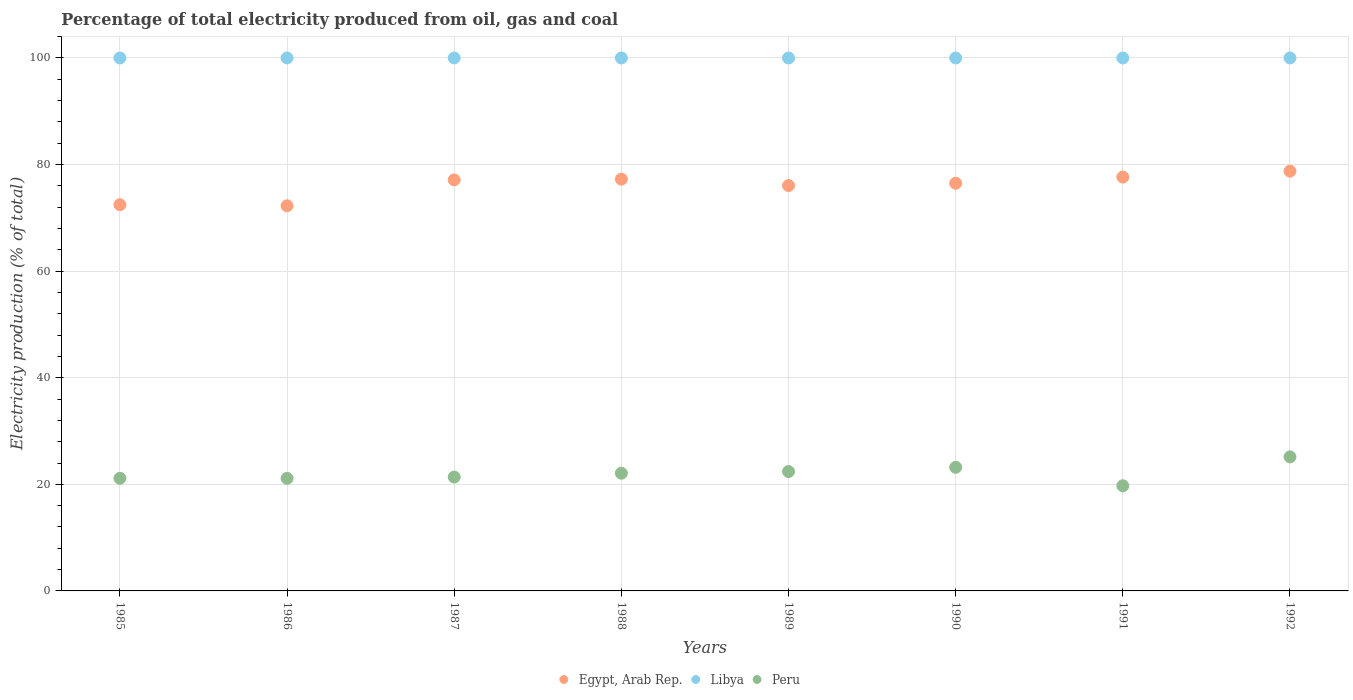Is the number of dotlines equal to the number of legend labels?
Your answer should be very brief. Yes. What is the electricity production in in Peru in 1985?
Offer a very short reply. 21.14. Across all years, what is the minimum electricity production in in Libya?
Offer a very short reply. 100. In which year was the electricity production in in Libya maximum?
Your response must be concise. 1985. In which year was the electricity production in in Egypt, Arab Rep. minimum?
Your answer should be very brief. 1986. What is the total electricity production in in Egypt, Arab Rep. in the graph?
Your answer should be very brief. 608.07. What is the difference between the electricity production in in Peru in 1987 and that in 1992?
Your answer should be compact. -3.79. What is the difference between the electricity production in in Peru in 1985 and the electricity production in in Libya in 1989?
Give a very brief answer. -78.86. What is the average electricity production in in Egypt, Arab Rep. per year?
Provide a succinct answer. 76.01. In the year 1992, what is the difference between the electricity production in in Peru and electricity production in in Egypt, Arab Rep.?
Ensure brevity in your answer.  -53.62. What is the ratio of the electricity production in in Egypt, Arab Rep. in 1987 to that in 1989?
Your response must be concise. 1.01. Is the difference between the electricity production in in Peru in 1987 and 1988 greater than the difference between the electricity production in in Egypt, Arab Rep. in 1987 and 1988?
Offer a very short reply. No. What is the difference between the highest and the second highest electricity production in in Peru?
Your answer should be compact. 1.95. What is the difference between the highest and the lowest electricity production in in Libya?
Provide a short and direct response. 0. In how many years, is the electricity production in in Egypt, Arab Rep. greater than the average electricity production in in Egypt, Arab Rep. taken over all years?
Provide a succinct answer. 6. Does the electricity production in in Egypt, Arab Rep. monotonically increase over the years?
Provide a succinct answer. No. Is the electricity production in in Egypt, Arab Rep. strictly less than the electricity production in in Libya over the years?
Make the answer very short. Yes. How many dotlines are there?
Offer a very short reply. 3. How many years are there in the graph?
Your response must be concise. 8. What is the difference between two consecutive major ticks on the Y-axis?
Provide a succinct answer. 20. Does the graph contain any zero values?
Keep it short and to the point. No. Where does the legend appear in the graph?
Make the answer very short. Bottom center. How many legend labels are there?
Offer a very short reply. 3. What is the title of the graph?
Your response must be concise. Percentage of total electricity produced from oil, gas and coal. What is the label or title of the X-axis?
Provide a succinct answer. Years. What is the label or title of the Y-axis?
Ensure brevity in your answer.  Electricity production (% of total). What is the Electricity production (% of total) of Egypt, Arab Rep. in 1985?
Your answer should be very brief. 72.46. What is the Electricity production (% of total) of Peru in 1985?
Keep it short and to the point. 21.14. What is the Electricity production (% of total) in Egypt, Arab Rep. in 1986?
Provide a succinct answer. 72.27. What is the Electricity production (% of total) in Peru in 1986?
Provide a succinct answer. 21.12. What is the Electricity production (% of total) in Egypt, Arab Rep. in 1987?
Offer a very short reply. 77.12. What is the Electricity production (% of total) in Peru in 1987?
Provide a succinct answer. 21.36. What is the Electricity production (% of total) in Egypt, Arab Rep. in 1988?
Your answer should be very brief. 77.26. What is the Electricity production (% of total) of Libya in 1988?
Offer a very short reply. 100. What is the Electricity production (% of total) in Peru in 1988?
Provide a short and direct response. 22.09. What is the Electricity production (% of total) of Egypt, Arab Rep. in 1989?
Your answer should be compact. 76.05. What is the Electricity production (% of total) in Libya in 1989?
Ensure brevity in your answer.  100. What is the Electricity production (% of total) of Peru in 1989?
Ensure brevity in your answer.  22.4. What is the Electricity production (% of total) in Egypt, Arab Rep. in 1990?
Ensure brevity in your answer.  76.5. What is the Electricity production (% of total) of Libya in 1990?
Offer a terse response. 100. What is the Electricity production (% of total) of Peru in 1990?
Your answer should be compact. 23.2. What is the Electricity production (% of total) in Egypt, Arab Rep. in 1991?
Your answer should be compact. 77.65. What is the Electricity production (% of total) of Libya in 1991?
Your response must be concise. 100. What is the Electricity production (% of total) in Peru in 1991?
Provide a short and direct response. 19.73. What is the Electricity production (% of total) of Egypt, Arab Rep. in 1992?
Provide a short and direct response. 78.76. What is the Electricity production (% of total) of Peru in 1992?
Your response must be concise. 25.15. Across all years, what is the maximum Electricity production (% of total) of Egypt, Arab Rep.?
Offer a very short reply. 78.76. Across all years, what is the maximum Electricity production (% of total) of Peru?
Provide a short and direct response. 25.15. Across all years, what is the minimum Electricity production (% of total) of Egypt, Arab Rep.?
Offer a very short reply. 72.27. Across all years, what is the minimum Electricity production (% of total) of Libya?
Your answer should be very brief. 100. Across all years, what is the minimum Electricity production (% of total) of Peru?
Provide a short and direct response. 19.73. What is the total Electricity production (% of total) in Egypt, Arab Rep. in the graph?
Provide a succinct answer. 608.07. What is the total Electricity production (% of total) in Libya in the graph?
Offer a terse response. 800. What is the total Electricity production (% of total) in Peru in the graph?
Give a very brief answer. 176.18. What is the difference between the Electricity production (% of total) of Egypt, Arab Rep. in 1985 and that in 1986?
Ensure brevity in your answer.  0.2. What is the difference between the Electricity production (% of total) in Peru in 1985 and that in 1986?
Provide a succinct answer. 0.02. What is the difference between the Electricity production (% of total) in Egypt, Arab Rep. in 1985 and that in 1987?
Ensure brevity in your answer.  -4.66. What is the difference between the Electricity production (% of total) in Libya in 1985 and that in 1987?
Provide a short and direct response. 0. What is the difference between the Electricity production (% of total) in Peru in 1985 and that in 1987?
Keep it short and to the point. -0.22. What is the difference between the Electricity production (% of total) of Egypt, Arab Rep. in 1985 and that in 1988?
Provide a short and direct response. -4.8. What is the difference between the Electricity production (% of total) in Libya in 1985 and that in 1988?
Ensure brevity in your answer.  0. What is the difference between the Electricity production (% of total) of Peru in 1985 and that in 1988?
Your answer should be very brief. -0.95. What is the difference between the Electricity production (% of total) of Egypt, Arab Rep. in 1985 and that in 1989?
Ensure brevity in your answer.  -3.59. What is the difference between the Electricity production (% of total) of Peru in 1985 and that in 1989?
Your answer should be compact. -1.26. What is the difference between the Electricity production (% of total) in Egypt, Arab Rep. in 1985 and that in 1990?
Offer a terse response. -4.03. What is the difference between the Electricity production (% of total) of Libya in 1985 and that in 1990?
Give a very brief answer. 0. What is the difference between the Electricity production (% of total) of Peru in 1985 and that in 1990?
Give a very brief answer. -2.06. What is the difference between the Electricity production (% of total) in Egypt, Arab Rep. in 1985 and that in 1991?
Offer a terse response. -5.19. What is the difference between the Electricity production (% of total) of Peru in 1985 and that in 1991?
Give a very brief answer. 1.41. What is the difference between the Electricity production (% of total) of Egypt, Arab Rep. in 1985 and that in 1992?
Give a very brief answer. -6.3. What is the difference between the Electricity production (% of total) of Libya in 1985 and that in 1992?
Offer a very short reply. 0. What is the difference between the Electricity production (% of total) of Peru in 1985 and that in 1992?
Ensure brevity in your answer.  -4.01. What is the difference between the Electricity production (% of total) of Egypt, Arab Rep. in 1986 and that in 1987?
Ensure brevity in your answer.  -4.86. What is the difference between the Electricity production (% of total) of Libya in 1986 and that in 1987?
Keep it short and to the point. 0. What is the difference between the Electricity production (% of total) in Peru in 1986 and that in 1987?
Offer a terse response. -0.25. What is the difference between the Electricity production (% of total) in Egypt, Arab Rep. in 1986 and that in 1988?
Provide a succinct answer. -5. What is the difference between the Electricity production (% of total) of Peru in 1986 and that in 1988?
Offer a very short reply. -0.97. What is the difference between the Electricity production (% of total) in Egypt, Arab Rep. in 1986 and that in 1989?
Give a very brief answer. -3.79. What is the difference between the Electricity production (% of total) of Peru in 1986 and that in 1989?
Offer a very short reply. -1.29. What is the difference between the Electricity production (% of total) in Egypt, Arab Rep. in 1986 and that in 1990?
Your answer should be compact. -4.23. What is the difference between the Electricity production (% of total) of Peru in 1986 and that in 1990?
Give a very brief answer. -2.08. What is the difference between the Electricity production (% of total) of Egypt, Arab Rep. in 1986 and that in 1991?
Offer a terse response. -5.38. What is the difference between the Electricity production (% of total) of Peru in 1986 and that in 1991?
Offer a very short reply. 1.39. What is the difference between the Electricity production (% of total) of Egypt, Arab Rep. in 1986 and that in 1992?
Offer a terse response. -6.5. What is the difference between the Electricity production (% of total) in Libya in 1986 and that in 1992?
Give a very brief answer. 0. What is the difference between the Electricity production (% of total) of Peru in 1986 and that in 1992?
Offer a terse response. -4.03. What is the difference between the Electricity production (% of total) of Egypt, Arab Rep. in 1987 and that in 1988?
Give a very brief answer. -0.14. What is the difference between the Electricity production (% of total) in Libya in 1987 and that in 1988?
Provide a short and direct response. 0. What is the difference between the Electricity production (% of total) of Peru in 1987 and that in 1988?
Make the answer very short. -0.72. What is the difference between the Electricity production (% of total) of Egypt, Arab Rep. in 1987 and that in 1989?
Ensure brevity in your answer.  1.07. What is the difference between the Electricity production (% of total) in Libya in 1987 and that in 1989?
Make the answer very short. 0. What is the difference between the Electricity production (% of total) of Peru in 1987 and that in 1989?
Keep it short and to the point. -1.04. What is the difference between the Electricity production (% of total) of Egypt, Arab Rep. in 1987 and that in 1990?
Your response must be concise. 0.63. What is the difference between the Electricity production (% of total) in Libya in 1987 and that in 1990?
Your answer should be very brief. 0. What is the difference between the Electricity production (% of total) of Peru in 1987 and that in 1990?
Give a very brief answer. -1.83. What is the difference between the Electricity production (% of total) of Egypt, Arab Rep. in 1987 and that in 1991?
Keep it short and to the point. -0.53. What is the difference between the Electricity production (% of total) of Peru in 1987 and that in 1991?
Keep it short and to the point. 1.63. What is the difference between the Electricity production (% of total) of Egypt, Arab Rep. in 1987 and that in 1992?
Give a very brief answer. -1.64. What is the difference between the Electricity production (% of total) in Peru in 1987 and that in 1992?
Offer a terse response. -3.79. What is the difference between the Electricity production (% of total) of Egypt, Arab Rep. in 1988 and that in 1989?
Your answer should be very brief. 1.21. What is the difference between the Electricity production (% of total) in Libya in 1988 and that in 1989?
Provide a short and direct response. 0. What is the difference between the Electricity production (% of total) of Peru in 1988 and that in 1989?
Offer a very short reply. -0.32. What is the difference between the Electricity production (% of total) of Egypt, Arab Rep. in 1988 and that in 1990?
Keep it short and to the point. 0.77. What is the difference between the Electricity production (% of total) of Libya in 1988 and that in 1990?
Your answer should be very brief. 0. What is the difference between the Electricity production (% of total) in Peru in 1988 and that in 1990?
Ensure brevity in your answer.  -1.11. What is the difference between the Electricity production (% of total) in Egypt, Arab Rep. in 1988 and that in 1991?
Provide a succinct answer. -0.39. What is the difference between the Electricity production (% of total) in Peru in 1988 and that in 1991?
Give a very brief answer. 2.36. What is the difference between the Electricity production (% of total) in Egypt, Arab Rep. in 1988 and that in 1992?
Give a very brief answer. -1.5. What is the difference between the Electricity production (% of total) of Libya in 1988 and that in 1992?
Your answer should be compact. 0. What is the difference between the Electricity production (% of total) in Peru in 1988 and that in 1992?
Provide a short and direct response. -3.06. What is the difference between the Electricity production (% of total) of Egypt, Arab Rep. in 1989 and that in 1990?
Your response must be concise. -0.44. What is the difference between the Electricity production (% of total) in Libya in 1989 and that in 1990?
Your answer should be very brief. 0. What is the difference between the Electricity production (% of total) in Peru in 1989 and that in 1990?
Offer a very short reply. -0.8. What is the difference between the Electricity production (% of total) in Egypt, Arab Rep. in 1989 and that in 1991?
Your answer should be compact. -1.6. What is the difference between the Electricity production (% of total) of Libya in 1989 and that in 1991?
Offer a terse response. 0. What is the difference between the Electricity production (% of total) in Peru in 1989 and that in 1991?
Your answer should be compact. 2.67. What is the difference between the Electricity production (% of total) in Egypt, Arab Rep. in 1989 and that in 1992?
Your answer should be compact. -2.71. What is the difference between the Electricity production (% of total) in Libya in 1989 and that in 1992?
Provide a short and direct response. 0. What is the difference between the Electricity production (% of total) of Peru in 1989 and that in 1992?
Provide a succinct answer. -2.75. What is the difference between the Electricity production (% of total) of Egypt, Arab Rep. in 1990 and that in 1991?
Your answer should be compact. -1.15. What is the difference between the Electricity production (% of total) in Libya in 1990 and that in 1991?
Give a very brief answer. 0. What is the difference between the Electricity production (% of total) in Peru in 1990 and that in 1991?
Keep it short and to the point. 3.47. What is the difference between the Electricity production (% of total) in Egypt, Arab Rep. in 1990 and that in 1992?
Provide a succinct answer. -2.27. What is the difference between the Electricity production (% of total) of Libya in 1990 and that in 1992?
Your answer should be compact. 0. What is the difference between the Electricity production (% of total) of Peru in 1990 and that in 1992?
Your answer should be compact. -1.95. What is the difference between the Electricity production (% of total) of Egypt, Arab Rep. in 1991 and that in 1992?
Provide a succinct answer. -1.11. What is the difference between the Electricity production (% of total) of Peru in 1991 and that in 1992?
Provide a short and direct response. -5.42. What is the difference between the Electricity production (% of total) in Egypt, Arab Rep. in 1985 and the Electricity production (% of total) in Libya in 1986?
Your answer should be very brief. -27.54. What is the difference between the Electricity production (% of total) in Egypt, Arab Rep. in 1985 and the Electricity production (% of total) in Peru in 1986?
Your answer should be compact. 51.35. What is the difference between the Electricity production (% of total) in Libya in 1985 and the Electricity production (% of total) in Peru in 1986?
Keep it short and to the point. 78.88. What is the difference between the Electricity production (% of total) of Egypt, Arab Rep. in 1985 and the Electricity production (% of total) of Libya in 1987?
Offer a very short reply. -27.54. What is the difference between the Electricity production (% of total) of Egypt, Arab Rep. in 1985 and the Electricity production (% of total) of Peru in 1987?
Ensure brevity in your answer.  51.1. What is the difference between the Electricity production (% of total) in Libya in 1985 and the Electricity production (% of total) in Peru in 1987?
Offer a terse response. 78.64. What is the difference between the Electricity production (% of total) in Egypt, Arab Rep. in 1985 and the Electricity production (% of total) in Libya in 1988?
Your answer should be compact. -27.54. What is the difference between the Electricity production (% of total) in Egypt, Arab Rep. in 1985 and the Electricity production (% of total) in Peru in 1988?
Offer a terse response. 50.38. What is the difference between the Electricity production (% of total) in Libya in 1985 and the Electricity production (% of total) in Peru in 1988?
Your answer should be very brief. 77.91. What is the difference between the Electricity production (% of total) in Egypt, Arab Rep. in 1985 and the Electricity production (% of total) in Libya in 1989?
Provide a succinct answer. -27.54. What is the difference between the Electricity production (% of total) of Egypt, Arab Rep. in 1985 and the Electricity production (% of total) of Peru in 1989?
Provide a succinct answer. 50.06. What is the difference between the Electricity production (% of total) in Libya in 1985 and the Electricity production (% of total) in Peru in 1989?
Provide a short and direct response. 77.6. What is the difference between the Electricity production (% of total) of Egypt, Arab Rep. in 1985 and the Electricity production (% of total) of Libya in 1990?
Make the answer very short. -27.54. What is the difference between the Electricity production (% of total) of Egypt, Arab Rep. in 1985 and the Electricity production (% of total) of Peru in 1990?
Your response must be concise. 49.27. What is the difference between the Electricity production (% of total) of Libya in 1985 and the Electricity production (% of total) of Peru in 1990?
Ensure brevity in your answer.  76.8. What is the difference between the Electricity production (% of total) in Egypt, Arab Rep. in 1985 and the Electricity production (% of total) in Libya in 1991?
Offer a terse response. -27.54. What is the difference between the Electricity production (% of total) of Egypt, Arab Rep. in 1985 and the Electricity production (% of total) of Peru in 1991?
Offer a terse response. 52.73. What is the difference between the Electricity production (% of total) in Libya in 1985 and the Electricity production (% of total) in Peru in 1991?
Ensure brevity in your answer.  80.27. What is the difference between the Electricity production (% of total) in Egypt, Arab Rep. in 1985 and the Electricity production (% of total) in Libya in 1992?
Your response must be concise. -27.54. What is the difference between the Electricity production (% of total) of Egypt, Arab Rep. in 1985 and the Electricity production (% of total) of Peru in 1992?
Your answer should be compact. 47.31. What is the difference between the Electricity production (% of total) of Libya in 1985 and the Electricity production (% of total) of Peru in 1992?
Offer a terse response. 74.85. What is the difference between the Electricity production (% of total) of Egypt, Arab Rep. in 1986 and the Electricity production (% of total) of Libya in 1987?
Your answer should be compact. -27.73. What is the difference between the Electricity production (% of total) in Egypt, Arab Rep. in 1986 and the Electricity production (% of total) in Peru in 1987?
Offer a very short reply. 50.9. What is the difference between the Electricity production (% of total) of Libya in 1986 and the Electricity production (% of total) of Peru in 1987?
Offer a very short reply. 78.64. What is the difference between the Electricity production (% of total) in Egypt, Arab Rep. in 1986 and the Electricity production (% of total) in Libya in 1988?
Ensure brevity in your answer.  -27.73. What is the difference between the Electricity production (% of total) in Egypt, Arab Rep. in 1986 and the Electricity production (% of total) in Peru in 1988?
Your answer should be very brief. 50.18. What is the difference between the Electricity production (% of total) of Libya in 1986 and the Electricity production (% of total) of Peru in 1988?
Provide a succinct answer. 77.91. What is the difference between the Electricity production (% of total) in Egypt, Arab Rep. in 1986 and the Electricity production (% of total) in Libya in 1989?
Keep it short and to the point. -27.73. What is the difference between the Electricity production (% of total) of Egypt, Arab Rep. in 1986 and the Electricity production (% of total) of Peru in 1989?
Ensure brevity in your answer.  49.86. What is the difference between the Electricity production (% of total) in Libya in 1986 and the Electricity production (% of total) in Peru in 1989?
Make the answer very short. 77.6. What is the difference between the Electricity production (% of total) in Egypt, Arab Rep. in 1986 and the Electricity production (% of total) in Libya in 1990?
Your answer should be very brief. -27.73. What is the difference between the Electricity production (% of total) of Egypt, Arab Rep. in 1986 and the Electricity production (% of total) of Peru in 1990?
Provide a short and direct response. 49.07. What is the difference between the Electricity production (% of total) of Libya in 1986 and the Electricity production (% of total) of Peru in 1990?
Your answer should be very brief. 76.8. What is the difference between the Electricity production (% of total) of Egypt, Arab Rep. in 1986 and the Electricity production (% of total) of Libya in 1991?
Provide a succinct answer. -27.73. What is the difference between the Electricity production (% of total) of Egypt, Arab Rep. in 1986 and the Electricity production (% of total) of Peru in 1991?
Ensure brevity in your answer.  52.54. What is the difference between the Electricity production (% of total) of Libya in 1986 and the Electricity production (% of total) of Peru in 1991?
Provide a short and direct response. 80.27. What is the difference between the Electricity production (% of total) in Egypt, Arab Rep. in 1986 and the Electricity production (% of total) in Libya in 1992?
Keep it short and to the point. -27.73. What is the difference between the Electricity production (% of total) of Egypt, Arab Rep. in 1986 and the Electricity production (% of total) of Peru in 1992?
Ensure brevity in your answer.  47.12. What is the difference between the Electricity production (% of total) of Libya in 1986 and the Electricity production (% of total) of Peru in 1992?
Give a very brief answer. 74.85. What is the difference between the Electricity production (% of total) of Egypt, Arab Rep. in 1987 and the Electricity production (% of total) of Libya in 1988?
Your answer should be compact. -22.88. What is the difference between the Electricity production (% of total) in Egypt, Arab Rep. in 1987 and the Electricity production (% of total) in Peru in 1988?
Keep it short and to the point. 55.04. What is the difference between the Electricity production (% of total) of Libya in 1987 and the Electricity production (% of total) of Peru in 1988?
Offer a very short reply. 77.91. What is the difference between the Electricity production (% of total) of Egypt, Arab Rep. in 1987 and the Electricity production (% of total) of Libya in 1989?
Provide a succinct answer. -22.88. What is the difference between the Electricity production (% of total) of Egypt, Arab Rep. in 1987 and the Electricity production (% of total) of Peru in 1989?
Provide a succinct answer. 54.72. What is the difference between the Electricity production (% of total) of Libya in 1987 and the Electricity production (% of total) of Peru in 1989?
Your answer should be compact. 77.6. What is the difference between the Electricity production (% of total) of Egypt, Arab Rep. in 1987 and the Electricity production (% of total) of Libya in 1990?
Offer a terse response. -22.88. What is the difference between the Electricity production (% of total) in Egypt, Arab Rep. in 1987 and the Electricity production (% of total) in Peru in 1990?
Offer a terse response. 53.93. What is the difference between the Electricity production (% of total) of Libya in 1987 and the Electricity production (% of total) of Peru in 1990?
Keep it short and to the point. 76.8. What is the difference between the Electricity production (% of total) of Egypt, Arab Rep. in 1987 and the Electricity production (% of total) of Libya in 1991?
Your answer should be very brief. -22.88. What is the difference between the Electricity production (% of total) in Egypt, Arab Rep. in 1987 and the Electricity production (% of total) in Peru in 1991?
Give a very brief answer. 57.39. What is the difference between the Electricity production (% of total) of Libya in 1987 and the Electricity production (% of total) of Peru in 1991?
Your answer should be compact. 80.27. What is the difference between the Electricity production (% of total) in Egypt, Arab Rep. in 1987 and the Electricity production (% of total) in Libya in 1992?
Keep it short and to the point. -22.88. What is the difference between the Electricity production (% of total) in Egypt, Arab Rep. in 1987 and the Electricity production (% of total) in Peru in 1992?
Make the answer very short. 51.97. What is the difference between the Electricity production (% of total) of Libya in 1987 and the Electricity production (% of total) of Peru in 1992?
Provide a short and direct response. 74.85. What is the difference between the Electricity production (% of total) of Egypt, Arab Rep. in 1988 and the Electricity production (% of total) of Libya in 1989?
Give a very brief answer. -22.74. What is the difference between the Electricity production (% of total) in Egypt, Arab Rep. in 1988 and the Electricity production (% of total) in Peru in 1989?
Offer a terse response. 54.86. What is the difference between the Electricity production (% of total) of Libya in 1988 and the Electricity production (% of total) of Peru in 1989?
Your answer should be very brief. 77.6. What is the difference between the Electricity production (% of total) of Egypt, Arab Rep. in 1988 and the Electricity production (% of total) of Libya in 1990?
Give a very brief answer. -22.74. What is the difference between the Electricity production (% of total) in Egypt, Arab Rep. in 1988 and the Electricity production (% of total) in Peru in 1990?
Ensure brevity in your answer.  54.06. What is the difference between the Electricity production (% of total) of Libya in 1988 and the Electricity production (% of total) of Peru in 1990?
Ensure brevity in your answer.  76.8. What is the difference between the Electricity production (% of total) of Egypt, Arab Rep. in 1988 and the Electricity production (% of total) of Libya in 1991?
Offer a very short reply. -22.74. What is the difference between the Electricity production (% of total) in Egypt, Arab Rep. in 1988 and the Electricity production (% of total) in Peru in 1991?
Ensure brevity in your answer.  57.53. What is the difference between the Electricity production (% of total) in Libya in 1988 and the Electricity production (% of total) in Peru in 1991?
Your answer should be compact. 80.27. What is the difference between the Electricity production (% of total) of Egypt, Arab Rep. in 1988 and the Electricity production (% of total) of Libya in 1992?
Keep it short and to the point. -22.74. What is the difference between the Electricity production (% of total) of Egypt, Arab Rep. in 1988 and the Electricity production (% of total) of Peru in 1992?
Offer a very short reply. 52.11. What is the difference between the Electricity production (% of total) of Libya in 1988 and the Electricity production (% of total) of Peru in 1992?
Ensure brevity in your answer.  74.85. What is the difference between the Electricity production (% of total) of Egypt, Arab Rep. in 1989 and the Electricity production (% of total) of Libya in 1990?
Give a very brief answer. -23.95. What is the difference between the Electricity production (% of total) of Egypt, Arab Rep. in 1989 and the Electricity production (% of total) of Peru in 1990?
Offer a very short reply. 52.86. What is the difference between the Electricity production (% of total) in Libya in 1989 and the Electricity production (% of total) in Peru in 1990?
Your answer should be compact. 76.8. What is the difference between the Electricity production (% of total) in Egypt, Arab Rep. in 1989 and the Electricity production (% of total) in Libya in 1991?
Offer a very short reply. -23.95. What is the difference between the Electricity production (% of total) of Egypt, Arab Rep. in 1989 and the Electricity production (% of total) of Peru in 1991?
Provide a succinct answer. 56.32. What is the difference between the Electricity production (% of total) of Libya in 1989 and the Electricity production (% of total) of Peru in 1991?
Your answer should be compact. 80.27. What is the difference between the Electricity production (% of total) of Egypt, Arab Rep. in 1989 and the Electricity production (% of total) of Libya in 1992?
Your answer should be very brief. -23.95. What is the difference between the Electricity production (% of total) of Egypt, Arab Rep. in 1989 and the Electricity production (% of total) of Peru in 1992?
Offer a very short reply. 50.9. What is the difference between the Electricity production (% of total) in Libya in 1989 and the Electricity production (% of total) in Peru in 1992?
Your response must be concise. 74.85. What is the difference between the Electricity production (% of total) of Egypt, Arab Rep. in 1990 and the Electricity production (% of total) of Libya in 1991?
Give a very brief answer. -23.5. What is the difference between the Electricity production (% of total) in Egypt, Arab Rep. in 1990 and the Electricity production (% of total) in Peru in 1991?
Make the answer very short. 56.77. What is the difference between the Electricity production (% of total) in Libya in 1990 and the Electricity production (% of total) in Peru in 1991?
Ensure brevity in your answer.  80.27. What is the difference between the Electricity production (% of total) in Egypt, Arab Rep. in 1990 and the Electricity production (% of total) in Libya in 1992?
Ensure brevity in your answer.  -23.5. What is the difference between the Electricity production (% of total) in Egypt, Arab Rep. in 1990 and the Electricity production (% of total) in Peru in 1992?
Your response must be concise. 51.35. What is the difference between the Electricity production (% of total) in Libya in 1990 and the Electricity production (% of total) in Peru in 1992?
Your answer should be compact. 74.85. What is the difference between the Electricity production (% of total) in Egypt, Arab Rep. in 1991 and the Electricity production (% of total) in Libya in 1992?
Your answer should be very brief. -22.35. What is the difference between the Electricity production (% of total) in Egypt, Arab Rep. in 1991 and the Electricity production (% of total) in Peru in 1992?
Provide a succinct answer. 52.5. What is the difference between the Electricity production (% of total) in Libya in 1991 and the Electricity production (% of total) in Peru in 1992?
Give a very brief answer. 74.85. What is the average Electricity production (% of total) in Egypt, Arab Rep. per year?
Your response must be concise. 76.01. What is the average Electricity production (% of total) in Libya per year?
Make the answer very short. 100. What is the average Electricity production (% of total) of Peru per year?
Give a very brief answer. 22.02. In the year 1985, what is the difference between the Electricity production (% of total) in Egypt, Arab Rep. and Electricity production (% of total) in Libya?
Give a very brief answer. -27.54. In the year 1985, what is the difference between the Electricity production (% of total) of Egypt, Arab Rep. and Electricity production (% of total) of Peru?
Make the answer very short. 51.32. In the year 1985, what is the difference between the Electricity production (% of total) in Libya and Electricity production (% of total) in Peru?
Offer a very short reply. 78.86. In the year 1986, what is the difference between the Electricity production (% of total) in Egypt, Arab Rep. and Electricity production (% of total) in Libya?
Make the answer very short. -27.73. In the year 1986, what is the difference between the Electricity production (% of total) of Egypt, Arab Rep. and Electricity production (% of total) of Peru?
Offer a very short reply. 51.15. In the year 1986, what is the difference between the Electricity production (% of total) of Libya and Electricity production (% of total) of Peru?
Make the answer very short. 78.88. In the year 1987, what is the difference between the Electricity production (% of total) of Egypt, Arab Rep. and Electricity production (% of total) of Libya?
Your response must be concise. -22.88. In the year 1987, what is the difference between the Electricity production (% of total) of Egypt, Arab Rep. and Electricity production (% of total) of Peru?
Give a very brief answer. 55.76. In the year 1987, what is the difference between the Electricity production (% of total) in Libya and Electricity production (% of total) in Peru?
Your answer should be very brief. 78.64. In the year 1988, what is the difference between the Electricity production (% of total) in Egypt, Arab Rep. and Electricity production (% of total) in Libya?
Offer a terse response. -22.74. In the year 1988, what is the difference between the Electricity production (% of total) in Egypt, Arab Rep. and Electricity production (% of total) in Peru?
Your answer should be compact. 55.18. In the year 1988, what is the difference between the Electricity production (% of total) of Libya and Electricity production (% of total) of Peru?
Ensure brevity in your answer.  77.91. In the year 1989, what is the difference between the Electricity production (% of total) of Egypt, Arab Rep. and Electricity production (% of total) of Libya?
Keep it short and to the point. -23.95. In the year 1989, what is the difference between the Electricity production (% of total) in Egypt, Arab Rep. and Electricity production (% of total) in Peru?
Ensure brevity in your answer.  53.65. In the year 1989, what is the difference between the Electricity production (% of total) of Libya and Electricity production (% of total) of Peru?
Your answer should be very brief. 77.6. In the year 1990, what is the difference between the Electricity production (% of total) of Egypt, Arab Rep. and Electricity production (% of total) of Libya?
Give a very brief answer. -23.5. In the year 1990, what is the difference between the Electricity production (% of total) in Egypt, Arab Rep. and Electricity production (% of total) in Peru?
Give a very brief answer. 53.3. In the year 1990, what is the difference between the Electricity production (% of total) in Libya and Electricity production (% of total) in Peru?
Provide a succinct answer. 76.8. In the year 1991, what is the difference between the Electricity production (% of total) of Egypt, Arab Rep. and Electricity production (% of total) of Libya?
Give a very brief answer. -22.35. In the year 1991, what is the difference between the Electricity production (% of total) of Egypt, Arab Rep. and Electricity production (% of total) of Peru?
Give a very brief answer. 57.92. In the year 1991, what is the difference between the Electricity production (% of total) in Libya and Electricity production (% of total) in Peru?
Offer a terse response. 80.27. In the year 1992, what is the difference between the Electricity production (% of total) in Egypt, Arab Rep. and Electricity production (% of total) in Libya?
Offer a terse response. -21.24. In the year 1992, what is the difference between the Electricity production (% of total) of Egypt, Arab Rep. and Electricity production (% of total) of Peru?
Offer a very short reply. 53.62. In the year 1992, what is the difference between the Electricity production (% of total) in Libya and Electricity production (% of total) in Peru?
Your response must be concise. 74.85. What is the ratio of the Electricity production (% of total) in Peru in 1985 to that in 1986?
Your answer should be compact. 1. What is the ratio of the Electricity production (% of total) in Egypt, Arab Rep. in 1985 to that in 1987?
Your answer should be very brief. 0.94. What is the ratio of the Electricity production (% of total) in Egypt, Arab Rep. in 1985 to that in 1988?
Provide a succinct answer. 0.94. What is the ratio of the Electricity production (% of total) in Peru in 1985 to that in 1988?
Ensure brevity in your answer.  0.96. What is the ratio of the Electricity production (% of total) of Egypt, Arab Rep. in 1985 to that in 1989?
Provide a succinct answer. 0.95. What is the ratio of the Electricity production (% of total) of Libya in 1985 to that in 1989?
Provide a short and direct response. 1. What is the ratio of the Electricity production (% of total) in Peru in 1985 to that in 1989?
Give a very brief answer. 0.94. What is the ratio of the Electricity production (% of total) in Egypt, Arab Rep. in 1985 to that in 1990?
Ensure brevity in your answer.  0.95. What is the ratio of the Electricity production (% of total) of Libya in 1985 to that in 1990?
Your response must be concise. 1. What is the ratio of the Electricity production (% of total) in Peru in 1985 to that in 1990?
Your answer should be compact. 0.91. What is the ratio of the Electricity production (% of total) in Egypt, Arab Rep. in 1985 to that in 1991?
Your response must be concise. 0.93. What is the ratio of the Electricity production (% of total) of Peru in 1985 to that in 1991?
Ensure brevity in your answer.  1.07. What is the ratio of the Electricity production (% of total) of Peru in 1985 to that in 1992?
Give a very brief answer. 0.84. What is the ratio of the Electricity production (% of total) in Egypt, Arab Rep. in 1986 to that in 1987?
Make the answer very short. 0.94. What is the ratio of the Electricity production (% of total) of Peru in 1986 to that in 1987?
Keep it short and to the point. 0.99. What is the ratio of the Electricity production (% of total) in Egypt, Arab Rep. in 1986 to that in 1988?
Provide a short and direct response. 0.94. What is the ratio of the Electricity production (% of total) of Libya in 1986 to that in 1988?
Your answer should be compact. 1. What is the ratio of the Electricity production (% of total) in Peru in 1986 to that in 1988?
Your answer should be very brief. 0.96. What is the ratio of the Electricity production (% of total) of Egypt, Arab Rep. in 1986 to that in 1989?
Offer a terse response. 0.95. What is the ratio of the Electricity production (% of total) of Peru in 1986 to that in 1989?
Offer a terse response. 0.94. What is the ratio of the Electricity production (% of total) in Egypt, Arab Rep. in 1986 to that in 1990?
Your answer should be very brief. 0.94. What is the ratio of the Electricity production (% of total) of Libya in 1986 to that in 1990?
Make the answer very short. 1. What is the ratio of the Electricity production (% of total) in Peru in 1986 to that in 1990?
Your answer should be very brief. 0.91. What is the ratio of the Electricity production (% of total) in Egypt, Arab Rep. in 1986 to that in 1991?
Offer a very short reply. 0.93. What is the ratio of the Electricity production (% of total) of Peru in 1986 to that in 1991?
Your answer should be very brief. 1.07. What is the ratio of the Electricity production (% of total) of Egypt, Arab Rep. in 1986 to that in 1992?
Offer a very short reply. 0.92. What is the ratio of the Electricity production (% of total) of Libya in 1986 to that in 1992?
Provide a succinct answer. 1. What is the ratio of the Electricity production (% of total) of Peru in 1986 to that in 1992?
Your answer should be compact. 0.84. What is the ratio of the Electricity production (% of total) of Egypt, Arab Rep. in 1987 to that in 1988?
Provide a succinct answer. 1. What is the ratio of the Electricity production (% of total) in Libya in 1987 to that in 1988?
Keep it short and to the point. 1. What is the ratio of the Electricity production (% of total) in Peru in 1987 to that in 1988?
Offer a very short reply. 0.97. What is the ratio of the Electricity production (% of total) in Egypt, Arab Rep. in 1987 to that in 1989?
Make the answer very short. 1.01. What is the ratio of the Electricity production (% of total) of Peru in 1987 to that in 1989?
Your answer should be very brief. 0.95. What is the ratio of the Electricity production (% of total) in Egypt, Arab Rep. in 1987 to that in 1990?
Make the answer very short. 1.01. What is the ratio of the Electricity production (% of total) of Peru in 1987 to that in 1990?
Make the answer very short. 0.92. What is the ratio of the Electricity production (% of total) in Peru in 1987 to that in 1991?
Make the answer very short. 1.08. What is the ratio of the Electricity production (% of total) in Egypt, Arab Rep. in 1987 to that in 1992?
Keep it short and to the point. 0.98. What is the ratio of the Electricity production (% of total) of Libya in 1987 to that in 1992?
Your response must be concise. 1. What is the ratio of the Electricity production (% of total) of Peru in 1987 to that in 1992?
Provide a short and direct response. 0.85. What is the ratio of the Electricity production (% of total) of Egypt, Arab Rep. in 1988 to that in 1989?
Provide a short and direct response. 1.02. What is the ratio of the Electricity production (% of total) of Libya in 1988 to that in 1989?
Your response must be concise. 1. What is the ratio of the Electricity production (% of total) in Peru in 1988 to that in 1989?
Provide a short and direct response. 0.99. What is the ratio of the Electricity production (% of total) in Egypt, Arab Rep. in 1988 to that in 1990?
Make the answer very short. 1.01. What is the ratio of the Electricity production (% of total) of Peru in 1988 to that in 1990?
Make the answer very short. 0.95. What is the ratio of the Electricity production (% of total) in Egypt, Arab Rep. in 1988 to that in 1991?
Provide a succinct answer. 0.99. What is the ratio of the Electricity production (% of total) in Peru in 1988 to that in 1991?
Make the answer very short. 1.12. What is the ratio of the Electricity production (% of total) of Egypt, Arab Rep. in 1988 to that in 1992?
Offer a terse response. 0.98. What is the ratio of the Electricity production (% of total) in Libya in 1988 to that in 1992?
Your answer should be very brief. 1. What is the ratio of the Electricity production (% of total) of Peru in 1988 to that in 1992?
Your response must be concise. 0.88. What is the ratio of the Electricity production (% of total) in Libya in 1989 to that in 1990?
Your response must be concise. 1. What is the ratio of the Electricity production (% of total) of Peru in 1989 to that in 1990?
Ensure brevity in your answer.  0.97. What is the ratio of the Electricity production (% of total) in Egypt, Arab Rep. in 1989 to that in 1991?
Your answer should be very brief. 0.98. What is the ratio of the Electricity production (% of total) of Peru in 1989 to that in 1991?
Your answer should be very brief. 1.14. What is the ratio of the Electricity production (% of total) of Egypt, Arab Rep. in 1989 to that in 1992?
Your response must be concise. 0.97. What is the ratio of the Electricity production (% of total) in Peru in 1989 to that in 1992?
Provide a short and direct response. 0.89. What is the ratio of the Electricity production (% of total) in Egypt, Arab Rep. in 1990 to that in 1991?
Provide a succinct answer. 0.99. What is the ratio of the Electricity production (% of total) in Peru in 1990 to that in 1991?
Offer a terse response. 1.18. What is the ratio of the Electricity production (% of total) of Egypt, Arab Rep. in 1990 to that in 1992?
Your answer should be compact. 0.97. What is the ratio of the Electricity production (% of total) of Libya in 1990 to that in 1992?
Offer a very short reply. 1. What is the ratio of the Electricity production (% of total) of Peru in 1990 to that in 1992?
Offer a very short reply. 0.92. What is the ratio of the Electricity production (% of total) of Egypt, Arab Rep. in 1991 to that in 1992?
Ensure brevity in your answer.  0.99. What is the ratio of the Electricity production (% of total) of Peru in 1991 to that in 1992?
Provide a succinct answer. 0.78. What is the difference between the highest and the second highest Electricity production (% of total) in Egypt, Arab Rep.?
Provide a succinct answer. 1.11. What is the difference between the highest and the second highest Electricity production (% of total) of Libya?
Keep it short and to the point. 0. What is the difference between the highest and the second highest Electricity production (% of total) in Peru?
Your response must be concise. 1.95. What is the difference between the highest and the lowest Electricity production (% of total) in Egypt, Arab Rep.?
Offer a very short reply. 6.5. What is the difference between the highest and the lowest Electricity production (% of total) of Libya?
Keep it short and to the point. 0. What is the difference between the highest and the lowest Electricity production (% of total) in Peru?
Your answer should be compact. 5.42. 